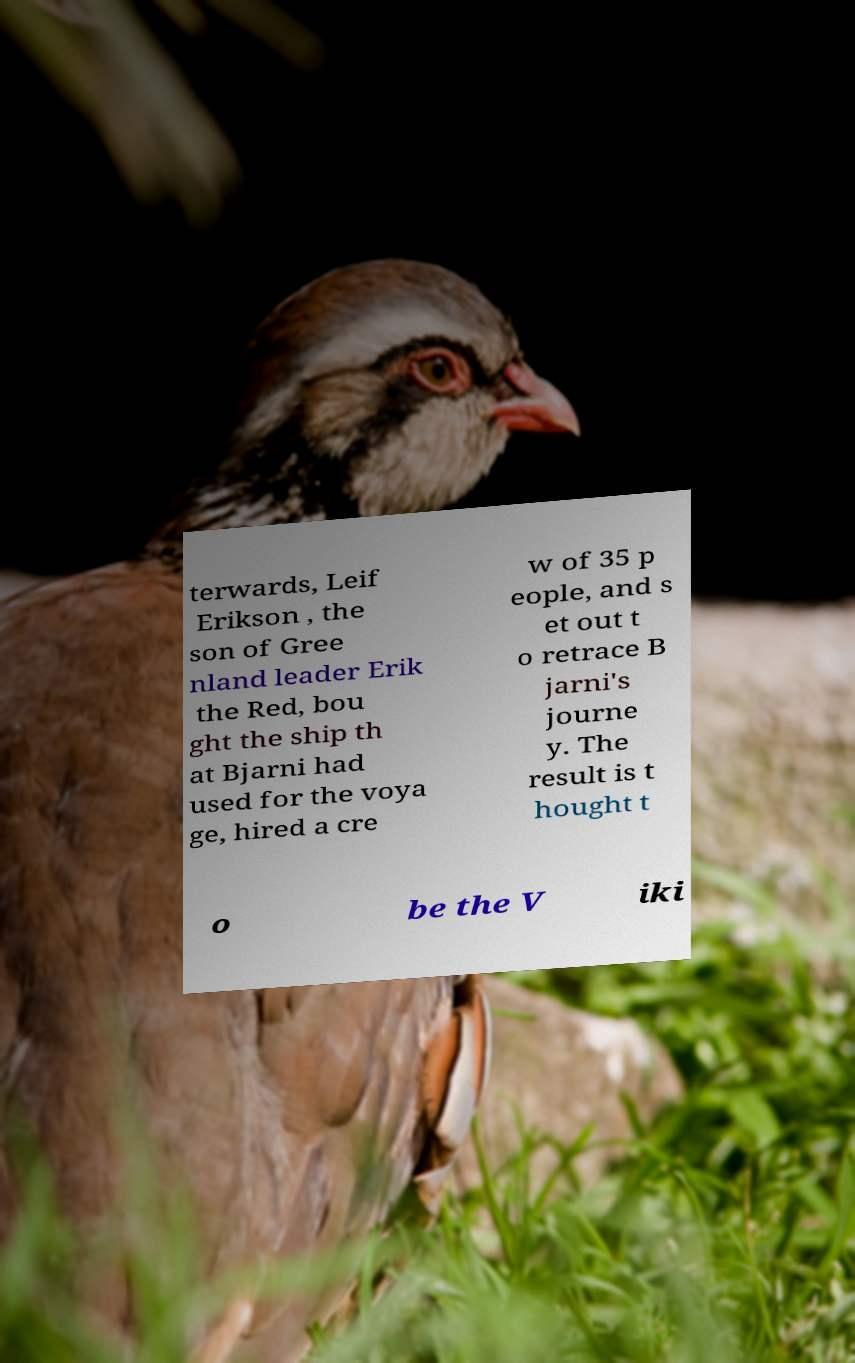For documentation purposes, I need the text within this image transcribed. Could you provide that? terwards, Leif Erikson , the son of Gree nland leader Erik the Red, bou ght the ship th at Bjarni had used for the voya ge, hired a cre w of 35 p eople, and s et out t o retrace B jarni's journe y. The result is t hought t o be the V iki 